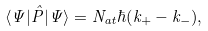<formula> <loc_0><loc_0><loc_500><loc_500>\langle \Psi | { \hat { P } } | \Psi \rangle = N _ { a t } \hbar { ( } k _ { + } - k _ { - } ) ,</formula> 